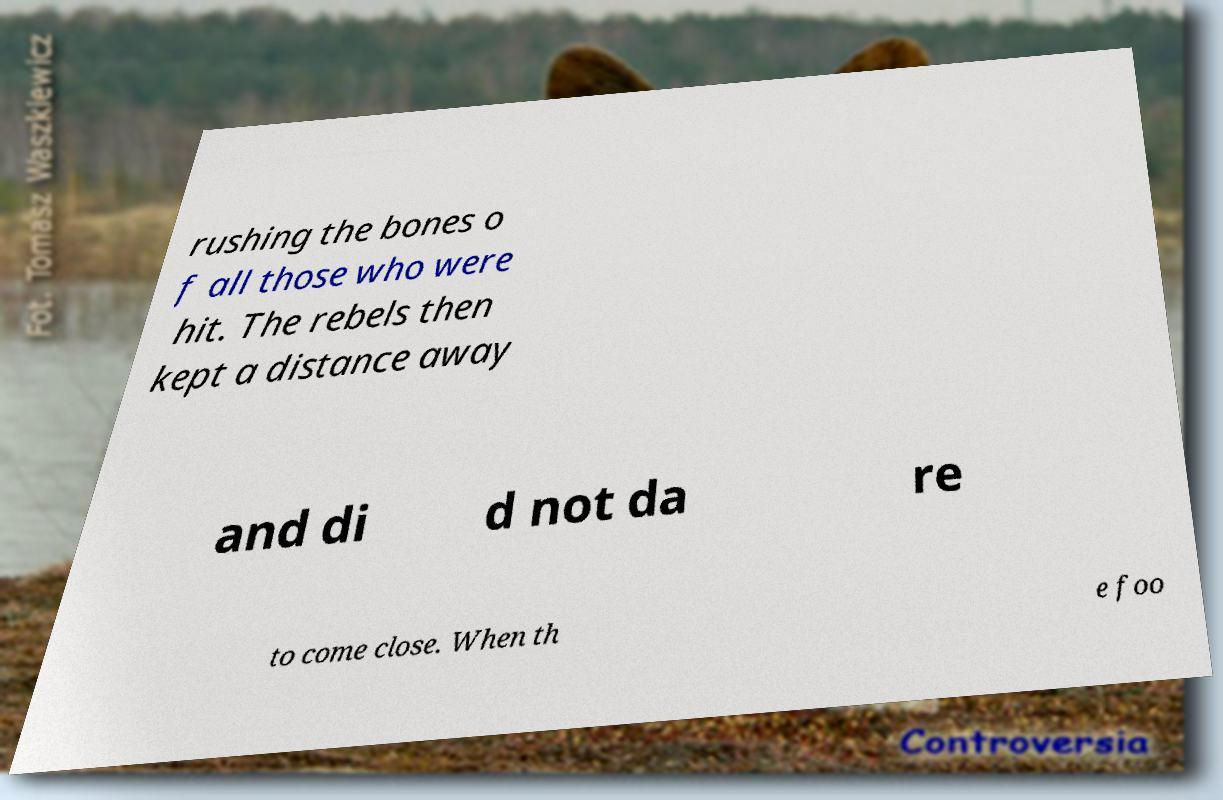I need the written content from this picture converted into text. Can you do that? rushing the bones o f all those who were hit. The rebels then kept a distance away and di d not da re to come close. When th e foo 